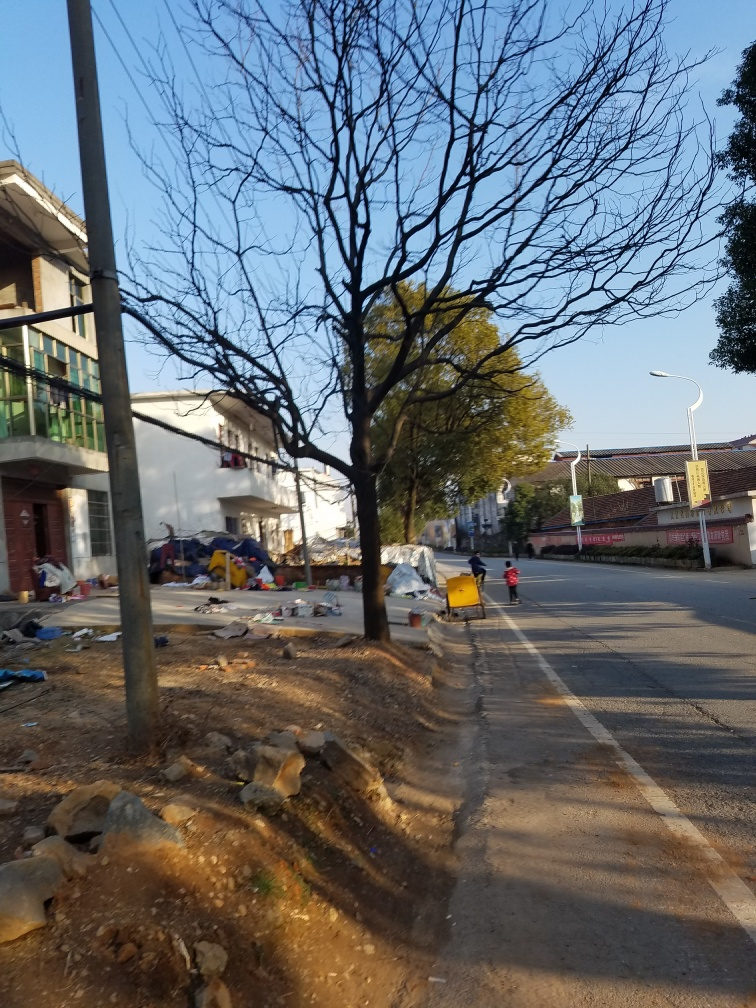Can you tell what time of day it might be based on the lighting in the image? The long shadows and the warm tone of the light suggest that the photo was taken during the late afternoon, possibly before sunset. What can you say about the condition of the sidewalk and the environment? The sidewalk appears to be in a state of disrepair with patches of earth showing, and there is a significant amount of litter and debris around, indicating a lack of maintenance or recent clean-up efforts. 